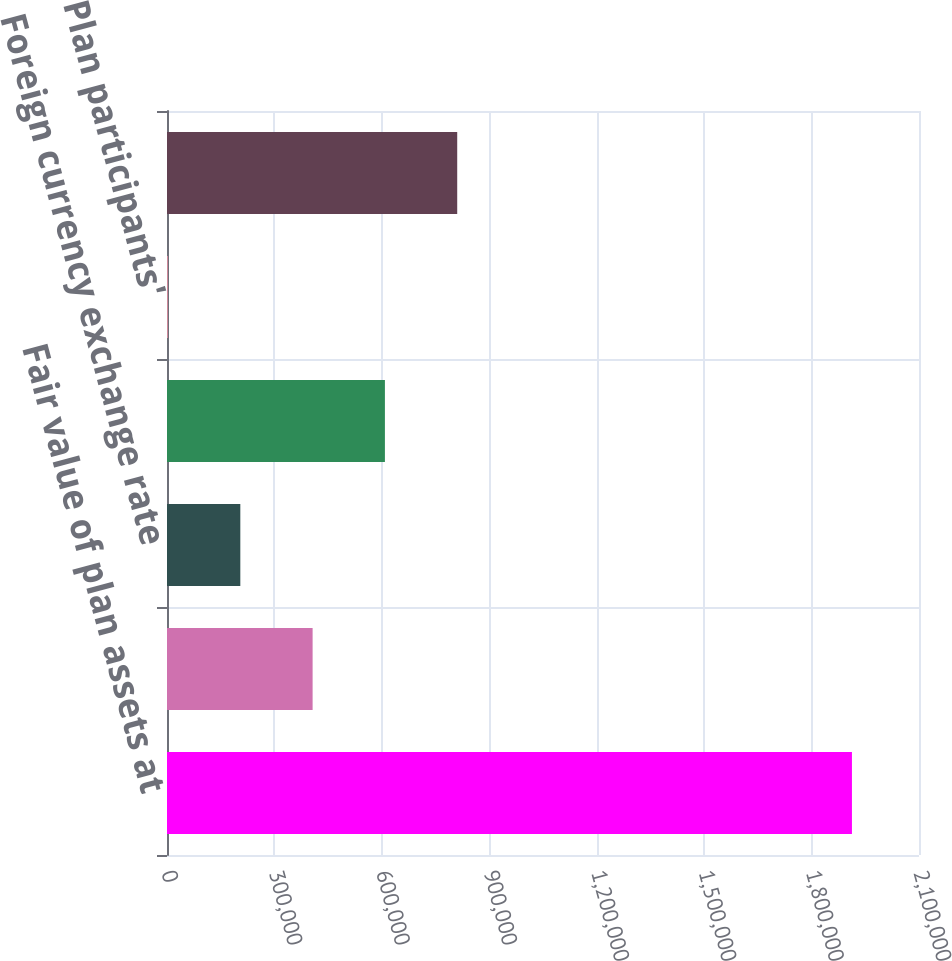<chart> <loc_0><loc_0><loc_500><loc_500><bar_chart><fcel>Fair value of plan assets at<fcel>Actual return on plan assets<fcel>Foreign currency exchange rate<fcel>Employer contributions<fcel>Plan participants'<fcel>Benefits paid<nl><fcel>1.91274e+06<fcel>406638<fcel>204738<fcel>608538<fcel>2838<fcel>810438<nl></chart> 